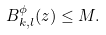Convert formula to latex. <formula><loc_0><loc_0><loc_500><loc_500>B ^ { \phi } _ { k , l } ( z ) \leq M .</formula> 